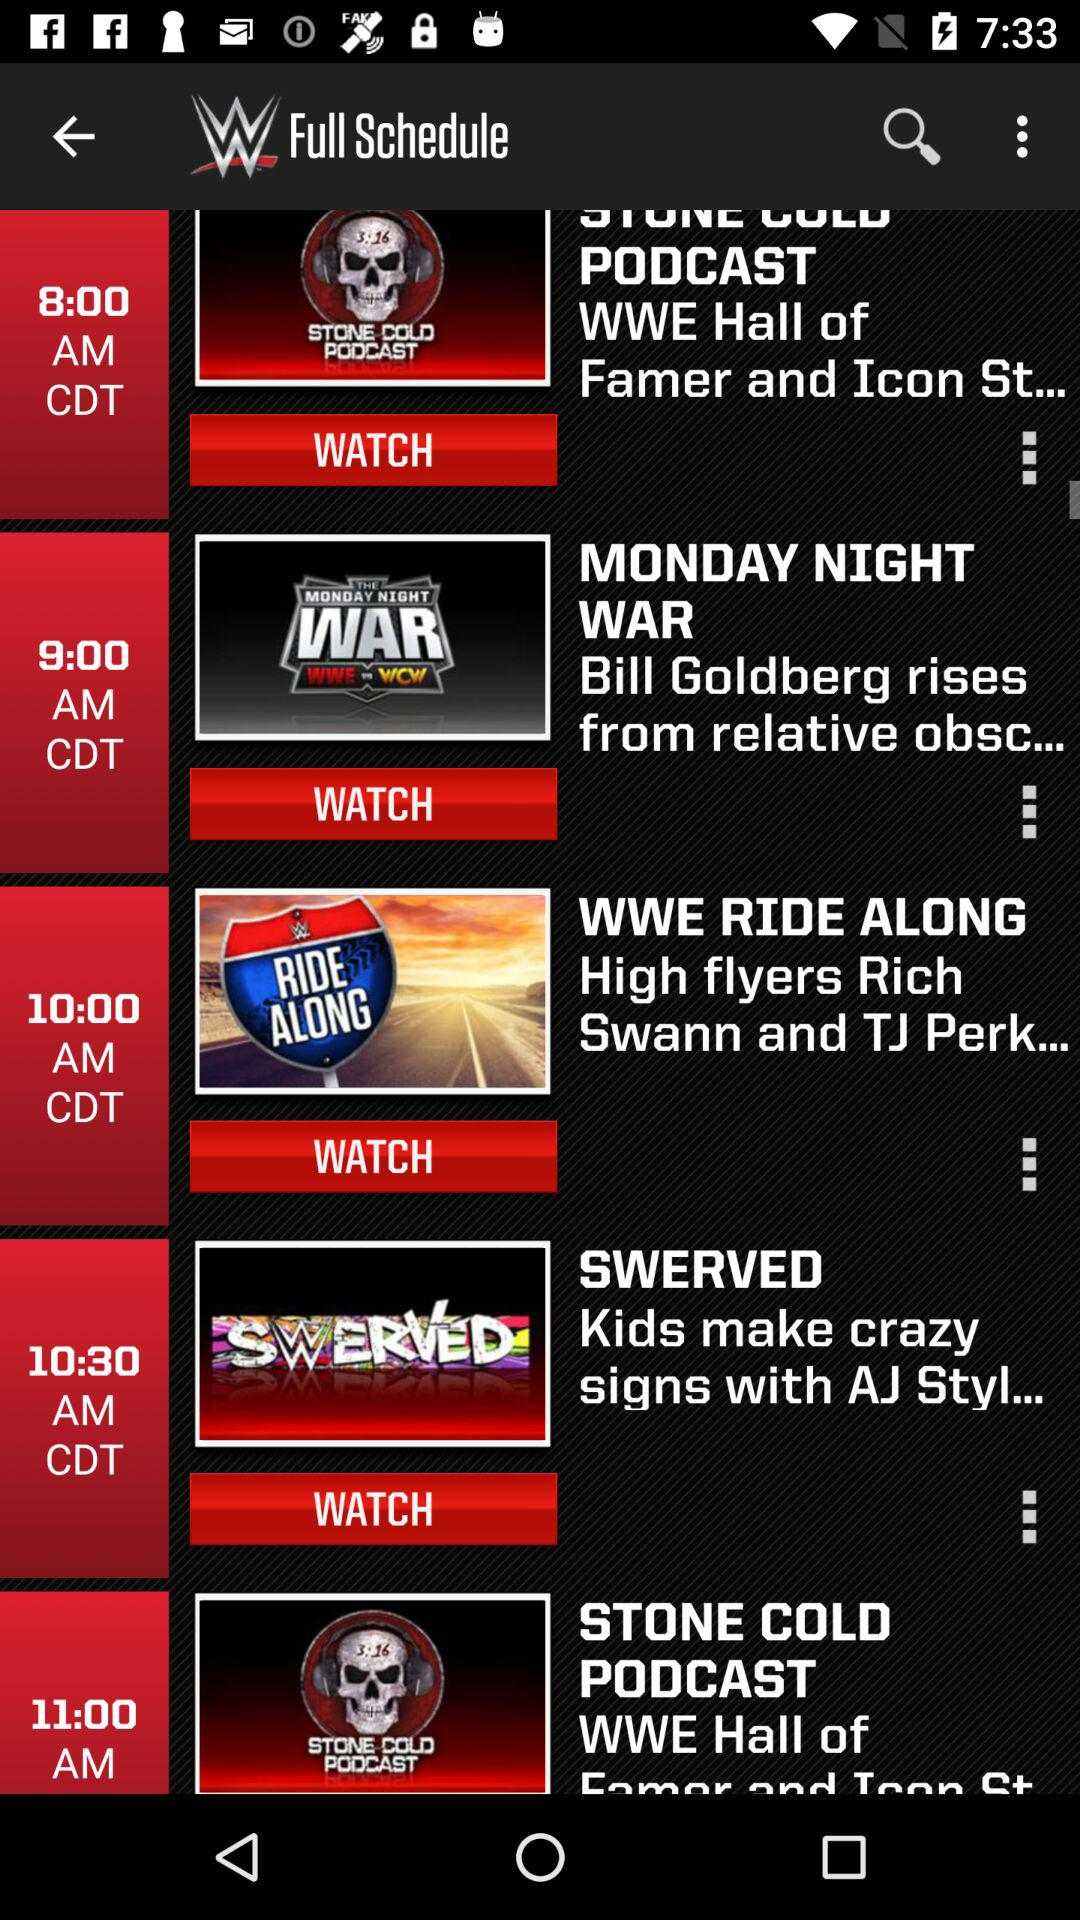What is the time of "STONE COLD PODCAST"? The time is 11:00 AM. 